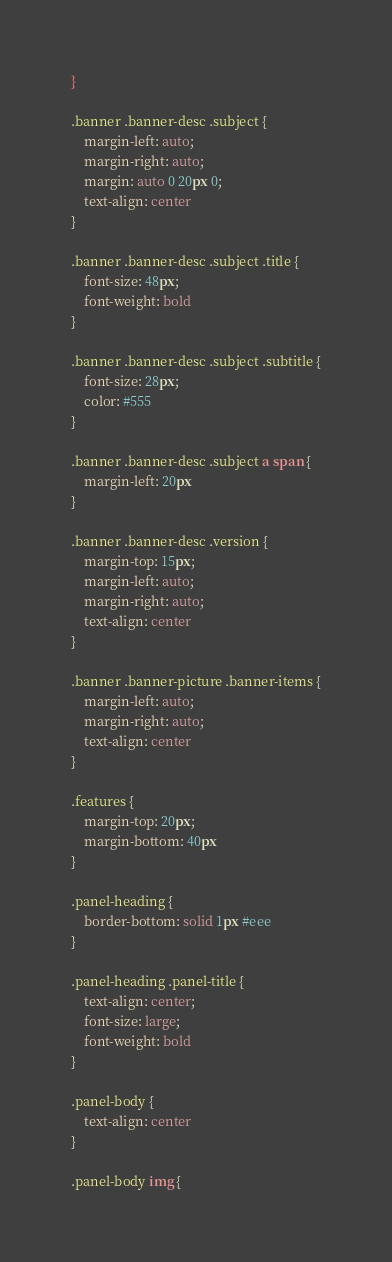Convert code to text. <code><loc_0><loc_0><loc_500><loc_500><_CSS_>}

.banner .banner-desc .subject {
    margin-left: auto;
    margin-right: auto;
    margin: auto 0 20px 0;
    text-align: center
}

.banner .banner-desc .subject .title {
    font-size: 48px;
    font-weight: bold
}

.banner .banner-desc .subject .subtitle {
    font-size: 28px;
    color: #555
}

.banner .banner-desc .subject a span {
    margin-left: 20px
}

.banner .banner-desc .version {
    margin-top: 15px;
    margin-left: auto;
    margin-right: auto;
    text-align: center
}

.banner .banner-picture .banner-items {
    margin-left: auto;
    margin-right: auto;
    text-align: center
}

.features {
    margin-top: 20px;
    margin-bottom: 40px
}

.panel-heading {
    border-bottom: solid 1px #eee
}

.panel-heading .panel-title {
    text-align: center;
    font-size: large;
    font-weight: bold
}

.panel-body {
    text-align: center
}

.panel-body img {</code> 